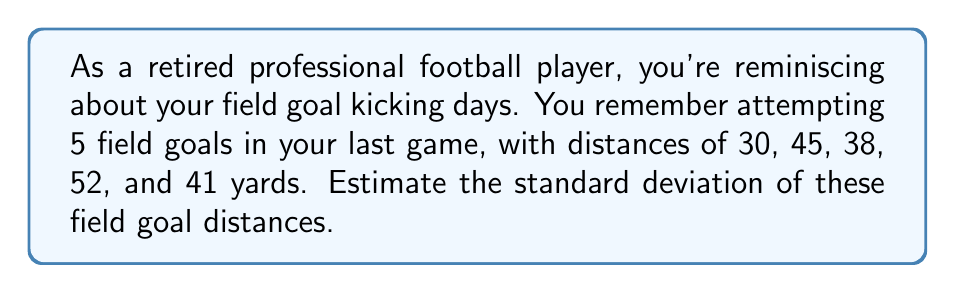Solve this math problem. To estimate the standard deviation, we'll follow these steps:

1. Calculate the mean (average) of the field goal distances:
   $$ \bar{x} = \frac{30 + 45 + 38 + 52 + 41}{5} = \frac{206}{5} = 41.2 \text{ yards} $$

2. Calculate the squared differences from the mean:
   $$(30 - 41.2)^2 = (-11.2)^2 = 125.44$$
   $$(45 - 41.2)^2 = (3.8)^2 = 14.44$$
   $$(38 - 41.2)^2 = (-3.2)^2 = 10.24$$
   $$(52 - 41.2)^2 = (10.8)^2 = 116.64$$
   $$(41 - 41.2)^2 = (-0.2)^2 = 0.04$$

3. Sum the squared differences:
   $$ 125.44 + 14.44 + 10.24 + 116.64 + 0.04 = 266.8 $$

4. Divide by (n-1) = 4 to get the variance:
   $$ s^2 = \frac{266.8}{4} = 66.7 $$

5. Take the square root to get the standard deviation:
   $$ s = \sqrt{66.7} \approx 8.17 \text{ yards} $$

Therefore, the estimated standard deviation of the field goal distances is approximately 8.17 yards.
Answer: $8.17 \text{ yards}$ 